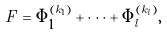<formula> <loc_0><loc_0><loc_500><loc_500>F = \Phi _ { 1 } ^ { ( k _ { 1 } ) } + \dots + \Phi _ { l } ^ { ( k _ { l } ) } ,</formula> 